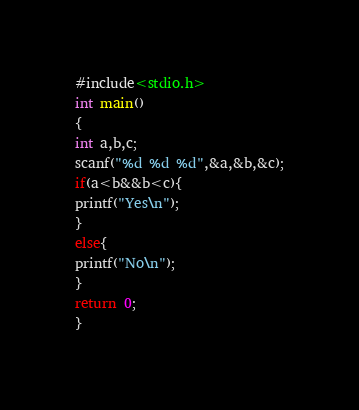Convert code to text. <code><loc_0><loc_0><loc_500><loc_500><_C_>#include<stdio.h>
int main()
{
int a,b,c;
scanf("%d %d %d",&a,&b,&c);
if(a<b&&b<c){
printf("Yes\n");
}
else{
printf("No\n");
}
return 0;
}</code> 